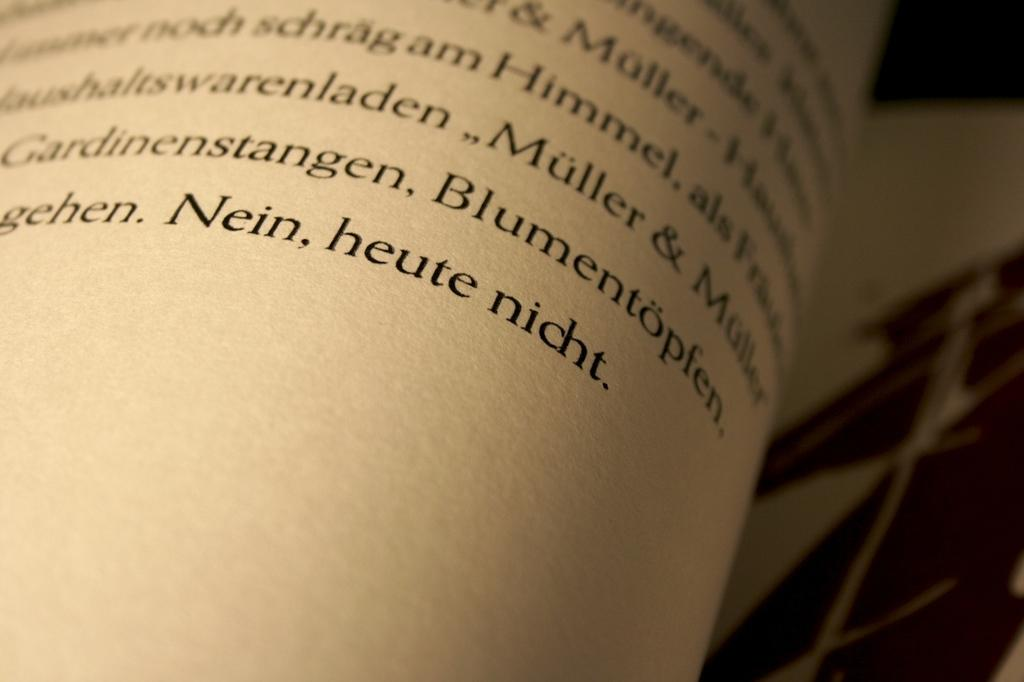<image>
Summarize the visual content of the image. Page from a book that ends with the word "Nein". 